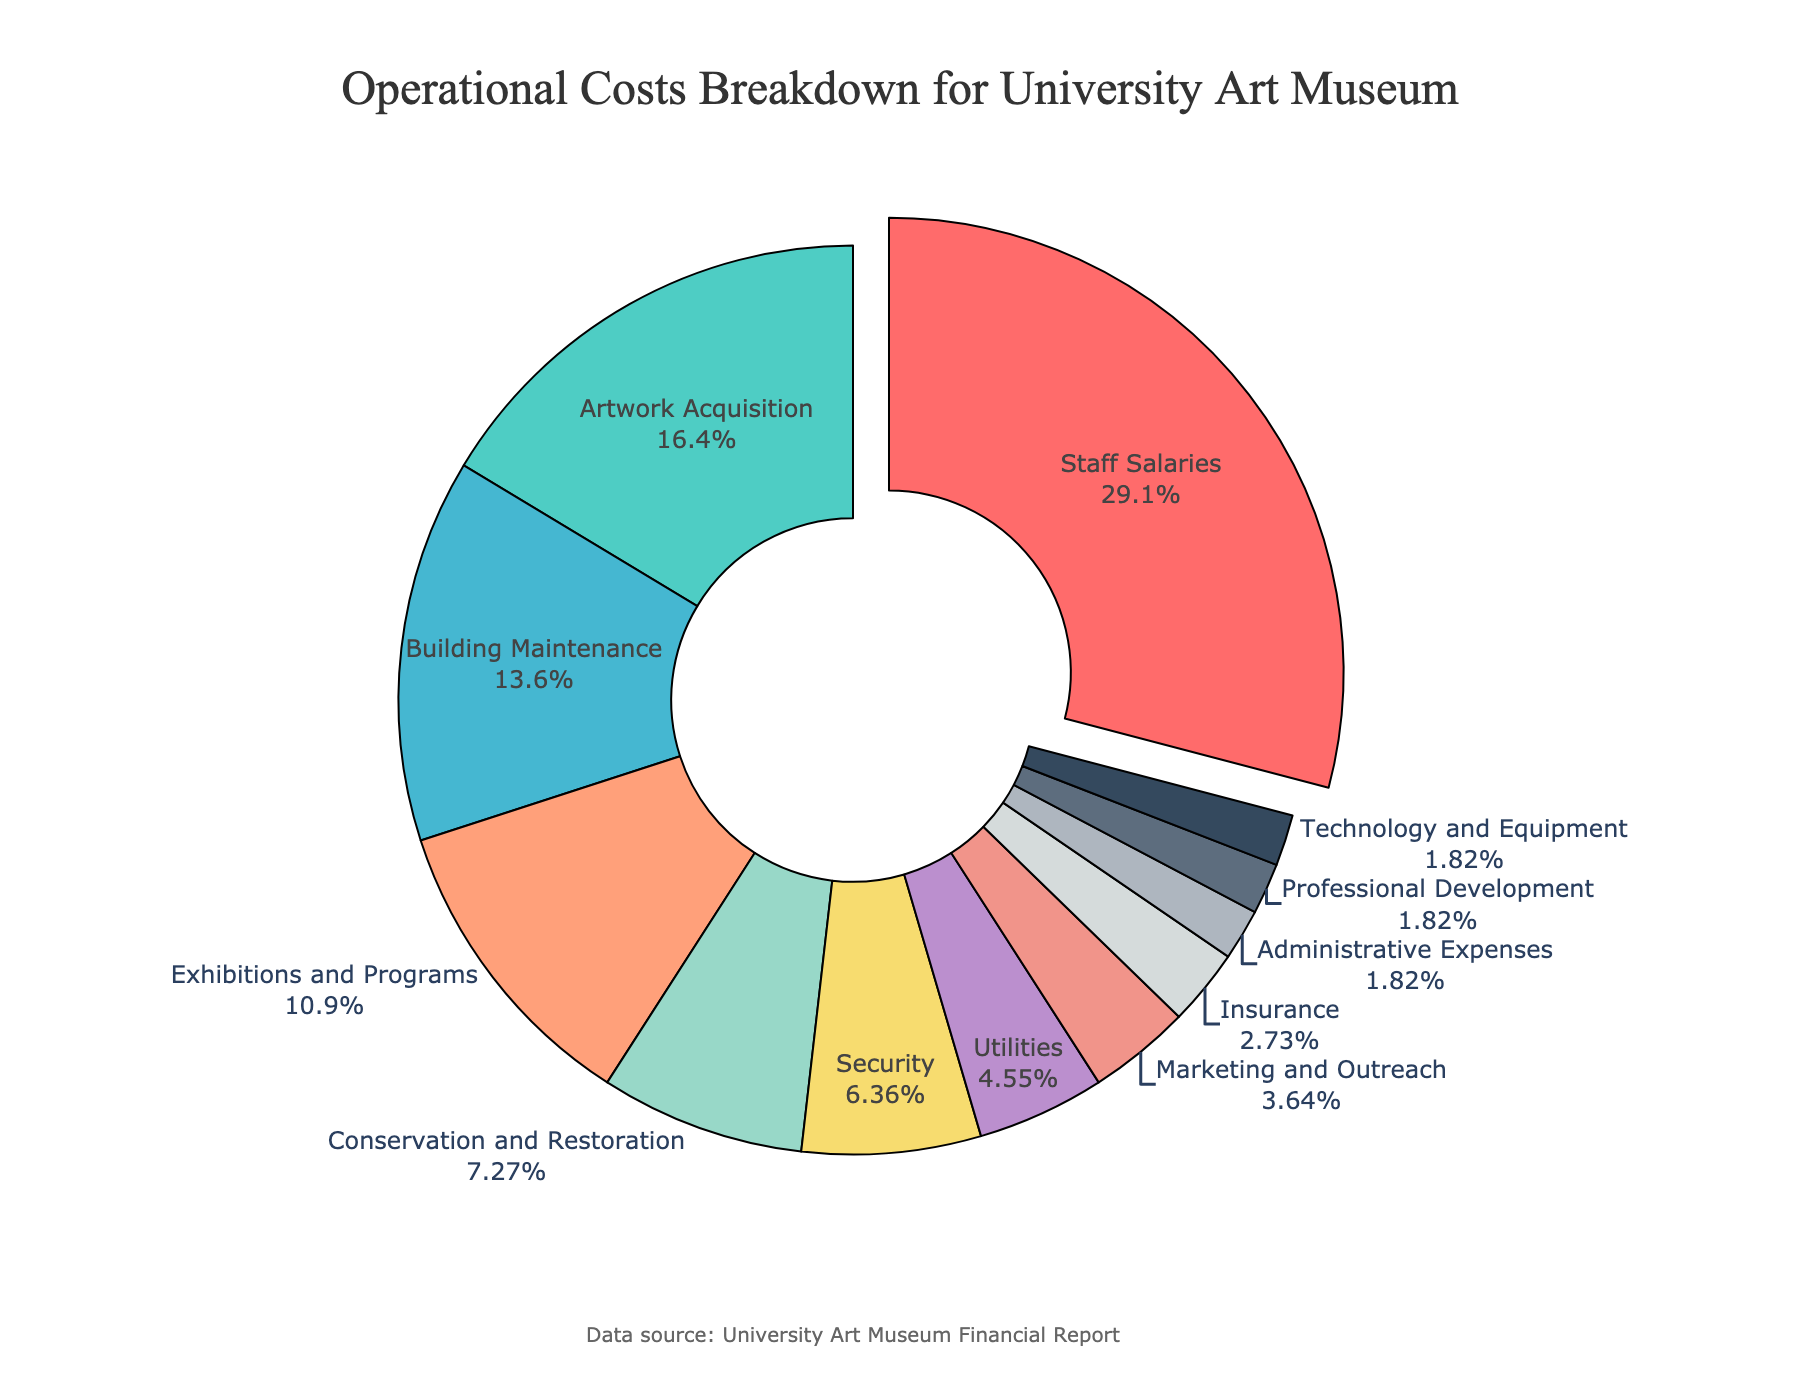What category accounts for the highest operational cost? The pie chart highlights the segment with the highest percentage by pulling it out slightly from the rest. The "Staff Salaries" segment is visually emphasized and shows 32%.
Answer: Staff Salaries Which categories together constitute 50% of the total costs? To determine which categories amount to 50% when their percentages are added together, we start from the highest value and proceed down. Adding "Staff Salaries" (32%) and "Artwork Acquisition" (18%) totals exactly 50%.
Answer: Staff Salaries and Artwork Acquisition What is the combined percentage of "Utilities" and "Marketing and Outreach"? Summing up the percentages of "Utilities" (5%) and "Marketing and Outreach" (4%) gives us a total of 9%.
Answer: 9% Which category's cost is just under the 10% threshold? We observe the pie chart for categories close to 10%. The "Conservation and Restoration" segment represents 8%, which is just under 10%.
Answer: Conservation and Restoration By how much does the percentage of "Building Maintenance" exceed that of "Utilities"? "Building Maintenance" is at 15% and "Utilities" is at 5%. Subtracting 5% from 15% gives a difference of 10%.
Answer: 10% What's the difference in percentage between the highest and lowest categories? The highest category is "Staff Salaries" at 32%, and the lowest categories are “Administrative Expenses,” "Professional Development," and "Technology and Equipment," all at 2%. The difference between 32% and 2% is 30%.
Answer: 30% How much more is spent on "Security" than on "Insurance"? The pie chart shows "Security" at 7% and "Insurance" at 3%. The difference is 7% - 3% = 4%.
Answer: 4% What is the second highest operational cost, and what percentage does it represent? After "Staff Salaries" (32%), the next highest percentage is "Artwork Acquisition" at 18%.
Answer: Artwork Acquisition, 18% What percentage of the costs is spent on categories related to maintenance and restoration? Adding "Building Maintenance" (15%) and "Conservation and Restoration" (8%) gives 23%.
Answer: 23% How many categories have a percentage of 5% or less? We count categories with percentages 5% or less: "Utilities" (5%), "Marketing and Outreach" (4%), "Insurance" (3%), "Administrative Expenses" (2%), "Professional Development" (2%), and "Technology and Equipment" (2%). There are 6.
Answer: 6 